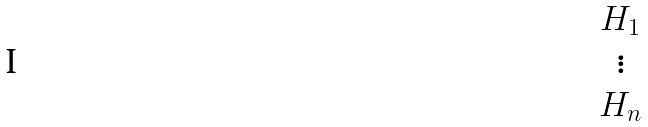Convert formula to latex. <formula><loc_0><loc_0><loc_500><loc_500>\begin{matrix} H _ { 1 } \\ \vdots \\ H _ { n } \end{matrix}</formula> 